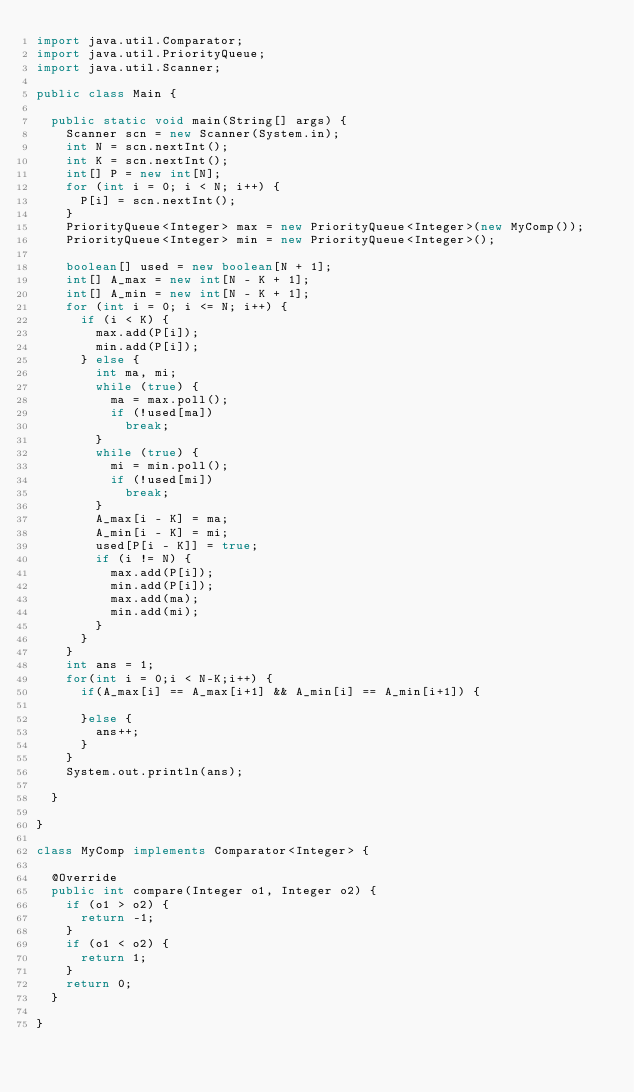<code> <loc_0><loc_0><loc_500><loc_500><_Java_>import java.util.Comparator;
import java.util.PriorityQueue;
import java.util.Scanner;

public class Main {

	public static void main(String[] args) {
		Scanner scn = new Scanner(System.in);
		int N = scn.nextInt();
		int K = scn.nextInt();
		int[] P = new int[N];
		for (int i = 0; i < N; i++) {
			P[i] = scn.nextInt();
		}
		PriorityQueue<Integer> max = new PriorityQueue<Integer>(new MyComp());
		PriorityQueue<Integer> min = new PriorityQueue<Integer>();

		boolean[] used = new boolean[N + 1];
		int[] A_max = new int[N - K + 1];
		int[] A_min = new int[N - K + 1];
		for (int i = 0; i <= N; i++) {
			if (i < K) {
				max.add(P[i]);
				min.add(P[i]);
			} else {
				int ma, mi;
				while (true) {
					ma = max.poll();
					if (!used[ma])
						break;
				}
				while (true) {
					mi = min.poll();
					if (!used[mi])
						break;
				}
				A_max[i - K] = ma;
				A_min[i - K] = mi;
				used[P[i - K]] = true;
				if (i != N) {
					max.add(P[i]);
					min.add(P[i]);
					max.add(ma);
					min.add(mi);
				}
			}
		}
		int ans = 1;
		for(int i = 0;i < N-K;i++) {
			if(A_max[i] == A_max[i+1] && A_min[i] == A_min[i+1]) {

			}else {
				ans++;
			}
		}
		System.out.println(ans);

	}

}

class MyComp implements Comparator<Integer> {

	@Override
	public int compare(Integer o1, Integer o2) {
		if (o1 > o2) {
			return -1;
		}
		if (o1 < o2) {
			return 1;
		}
		return 0;
	}

}
</code> 